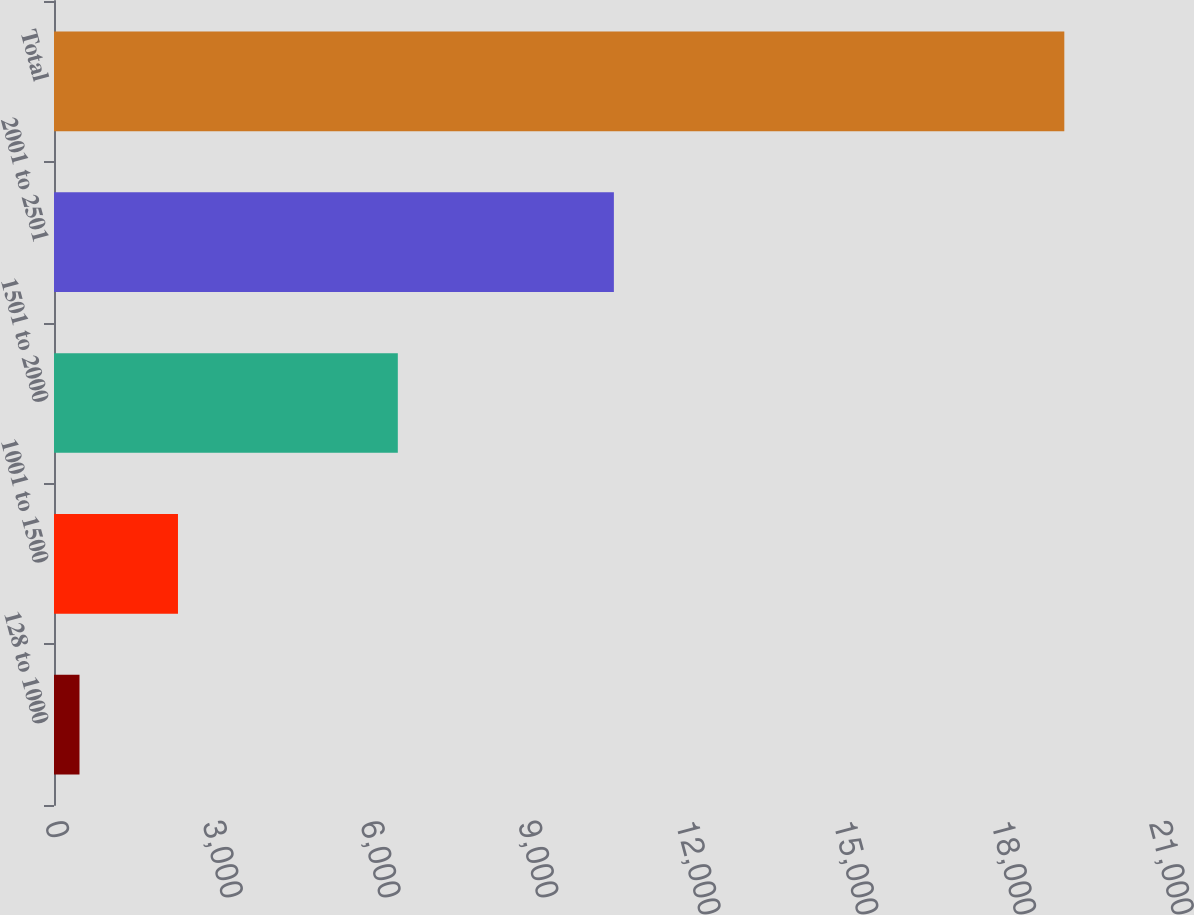Convert chart to OTSL. <chart><loc_0><loc_0><loc_500><loc_500><bar_chart><fcel>128 to 1000<fcel>1001 to 1500<fcel>1501 to 2000<fcel>2001 to 2501<fcel>Total<nl><fcel>485<fcel>2358.3<fcel>6540<fcel>10650<fcel>19218<nl></chart> 